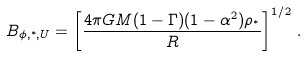Convert formula to latex. <formula><loc_0><loc_0><loc_500><loc_500>B _ { \phi , ^ { * } , U } = \left [ \frac { 4 \pi G M ( 1 - \Gamma ) ( 1 - \alpha ^ { 2 } ) \rho _ { ^ { * } } } { R } \right ] ^ { 1 / 2 } \, .</formula> 